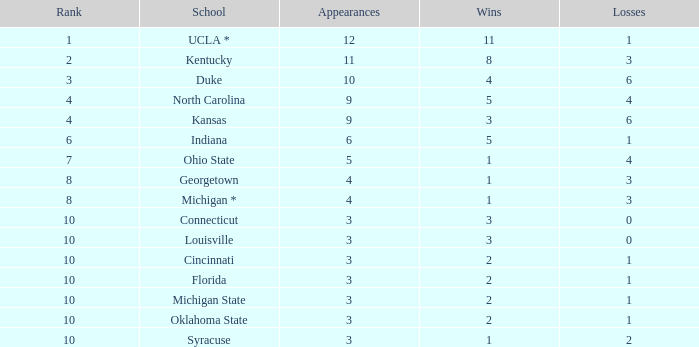Calculate the combined losses when there are fewer than 2 wins, a rank of 10, and more than 3 appearances. None. 